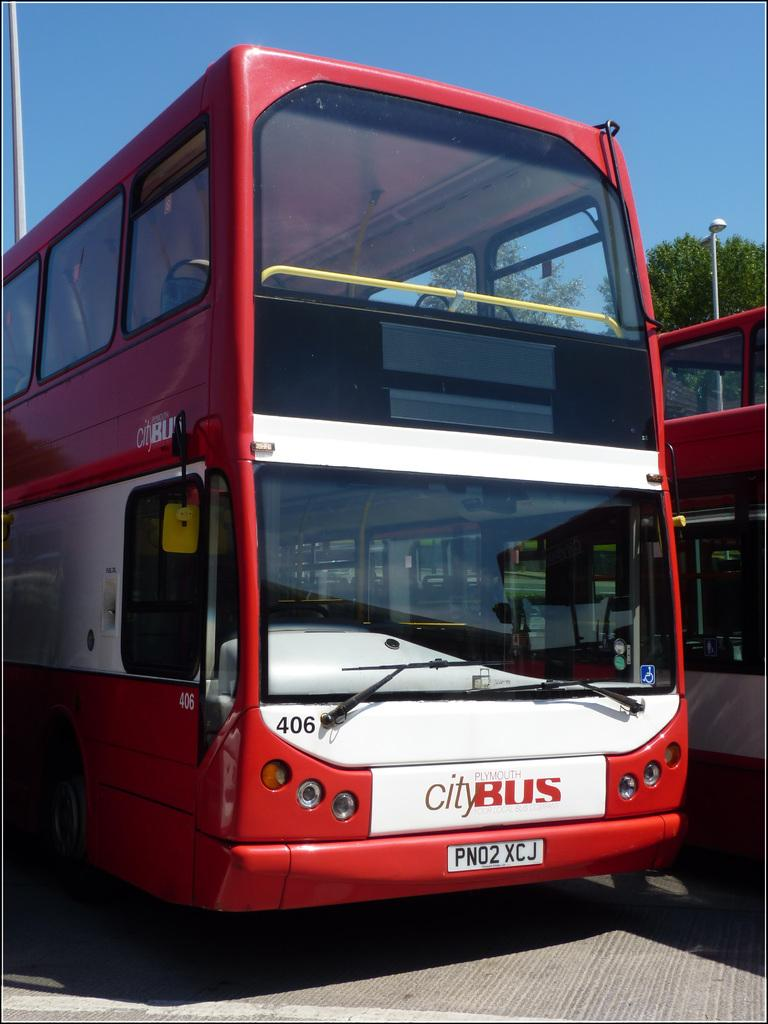What type of vehicles are parked on the floor in the image? There are buses parked on the floor in the image. What can be seen in the background of the image? There is a street light, trees, and the sky visible in the background of the image. What type of butter is being served on the plate in the image? There is no butter or plate present in the image; it features buses parked on the floor and a background with a street light, trees, and the sky. 